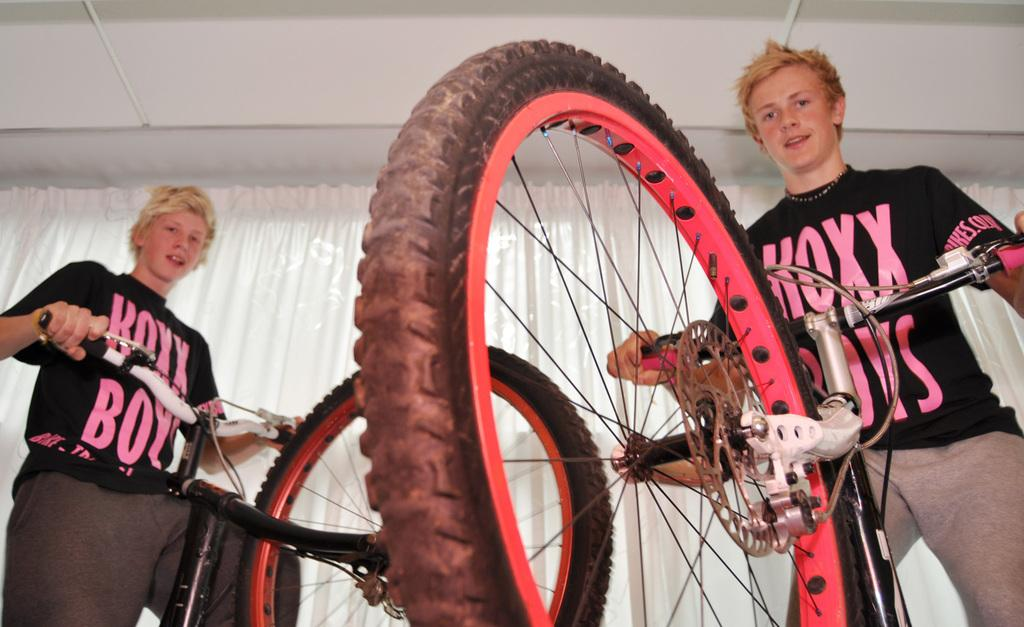What is the boy on the left side of the image doing? The boy on the left side of the image is playing with a cycle. What is the boy on the left side of the image wearing? The boy on the left side of the image is wearing a black color t-shirt. What is the second boy on the right side of the image holding? The second boy on the right side of the image is holding a cycle. What can be seen in the middle of the image? There is a curtain in the middle of the image. What type of tray is being used by the army in the image? There is no army or tray present in the image. Can you hear the boys talking in the image? The image is silent, so we cannot hear the boys talking. 